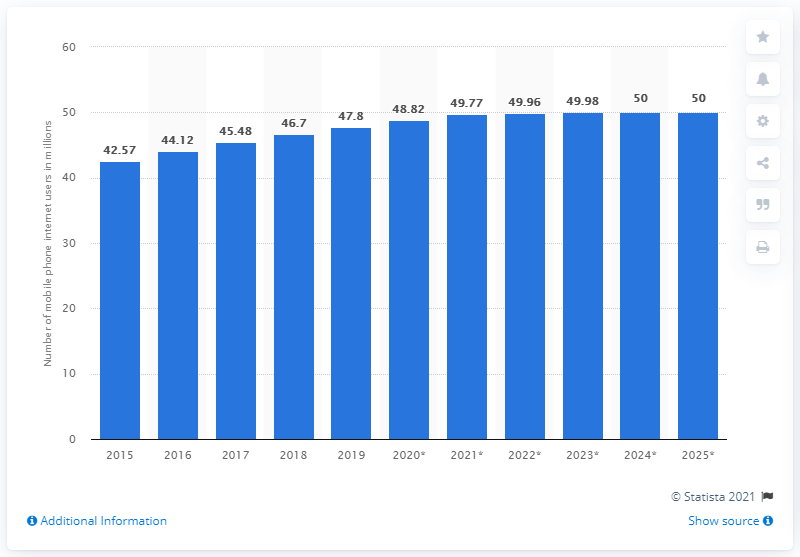Draw attention to some important aspects in this diagram. By 2025, it is projected that there will be approximately 50 million mobile phone internet users in South Korea. In 2019, it is estimated that 47.8% of the population in South Korea accessed the internet through their mobile phones. 